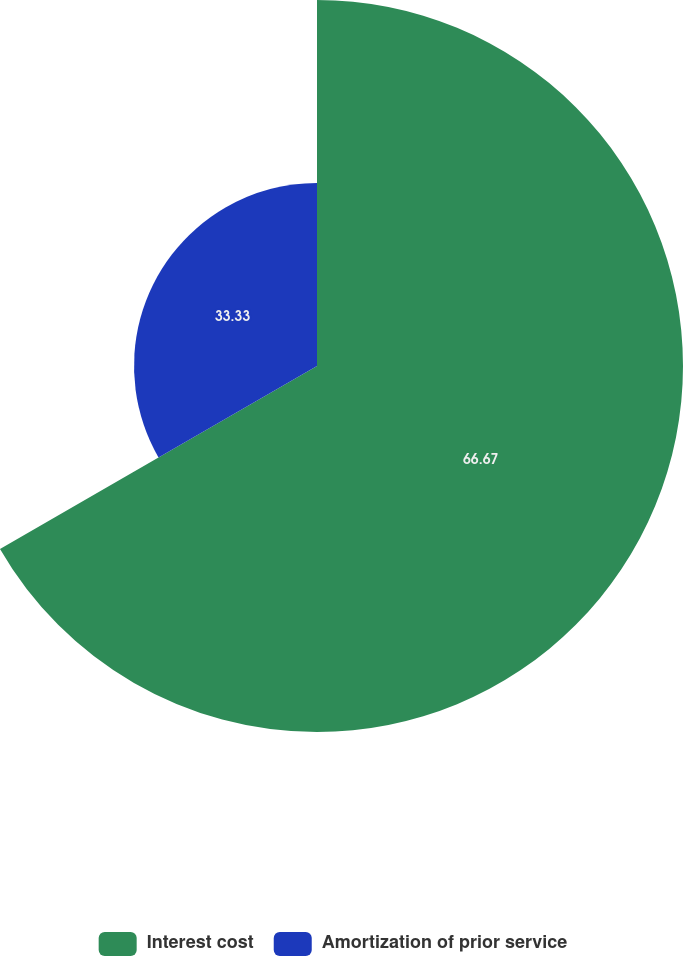Convert chart. <chart><loc_0><loc_0><loc_500><loc_500><pie_chart><fcel>Interest cost<fcel>Amortization of prior service<nl><fcel>66.67%<fcel>33.33%<nl></chart> 